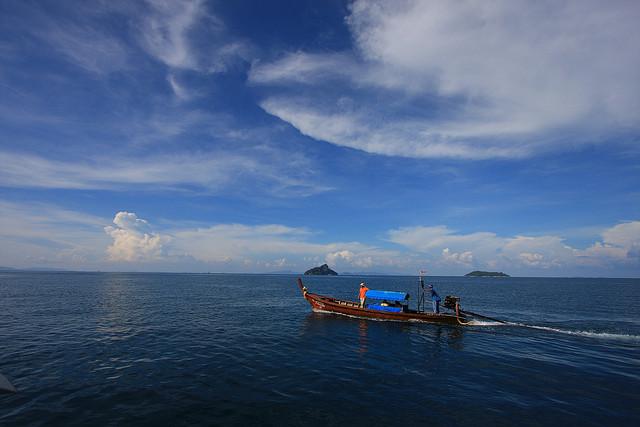Is this in black and white?
Quick response, please. No. What is the person sitting on?
Quick response, please. Boat. How many islands are visible?
Short answer required. 2. Where was this photo taken?
Answer briefly. Ocean. Which one of those boats is most likely to have a motor?
Give a very brief answer. Red one. Is this near a pier?
Quick response, please. No. Is the boat in water?
Quick response, please. Yes. Is there WI-Fi?
Keep it brief. No. Is the boat moving?
Answer briefly. Yes. How is this boat being propelled?
Quick response, please. Motor. Is the red boat new?
Write a very short answer. No. What kind of boat is this?
Keep it brief. Fishing boat. What color is the water?
Keep it brief. Blue. Was this taken on a boat or peer?
Give a very brief answer. Boat. How many boats are there?
Give a very brief answer. 1. How many boats are in the water?
Concise answer only. 1. Where is the water?
Be succinct. Ocean. Is the water calm?
Answer briefly. Yes. What number of boats are in this image?
Keep it brief. 1. 